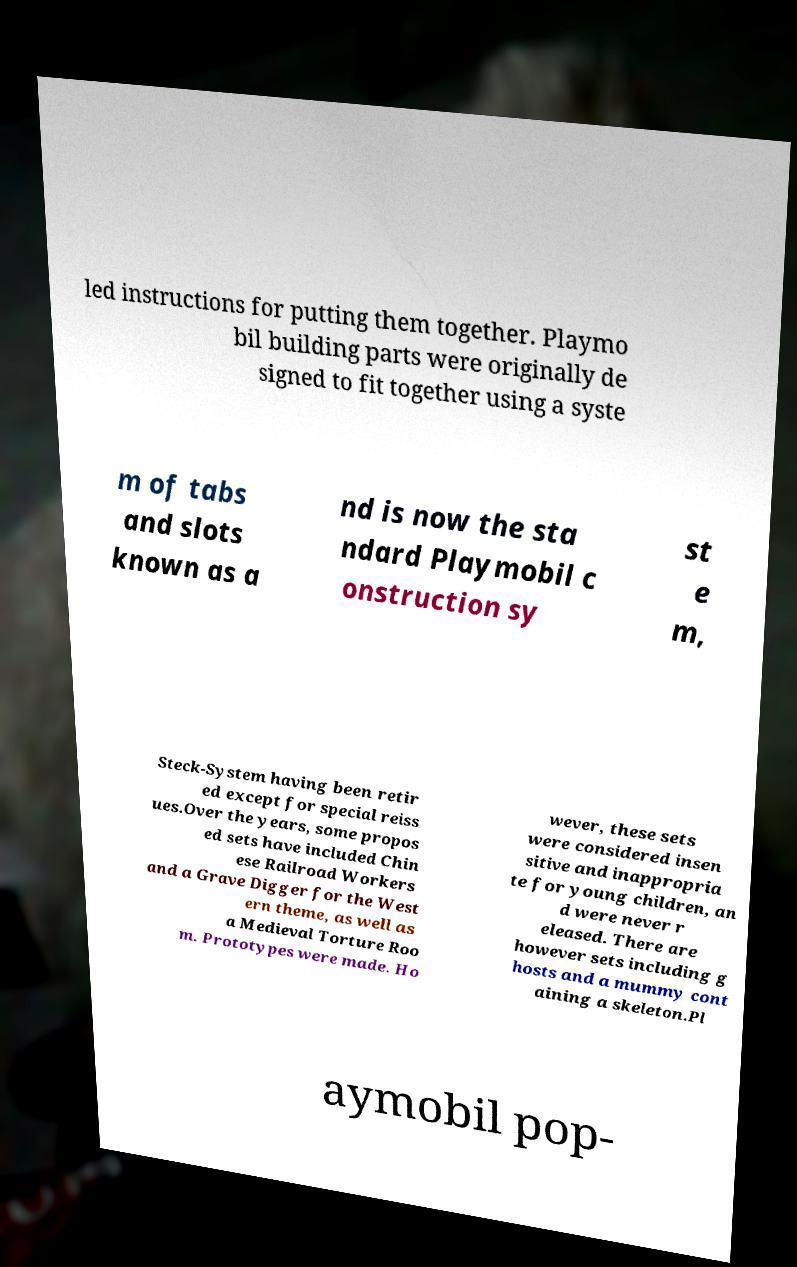Can you read and provide the text displayed in the image?This photo seems to have some interesting text. Can you extract and type it out for me? led instructions for putting them together. Playmo bil building parts were originally de signed to fit together using a syste m of tabs and slots known as a nd is now the sta ndard Playmobil c onstruction sy st e m, Steck-System having been retir ed except for special reiss ues.Over the years, some propos ed sets have included Chin ese Railroad Workers and a Grave Digger for the West ern theme, as well as a Medieval Torture Roo m. Prototypes were made. Ho wever, these sets were considered insen sitive and inappropria te for young children, an d were never r eleased. There are however sets including g hosts and a mummy cont aining a skeleton.Pl aymobil pop- 